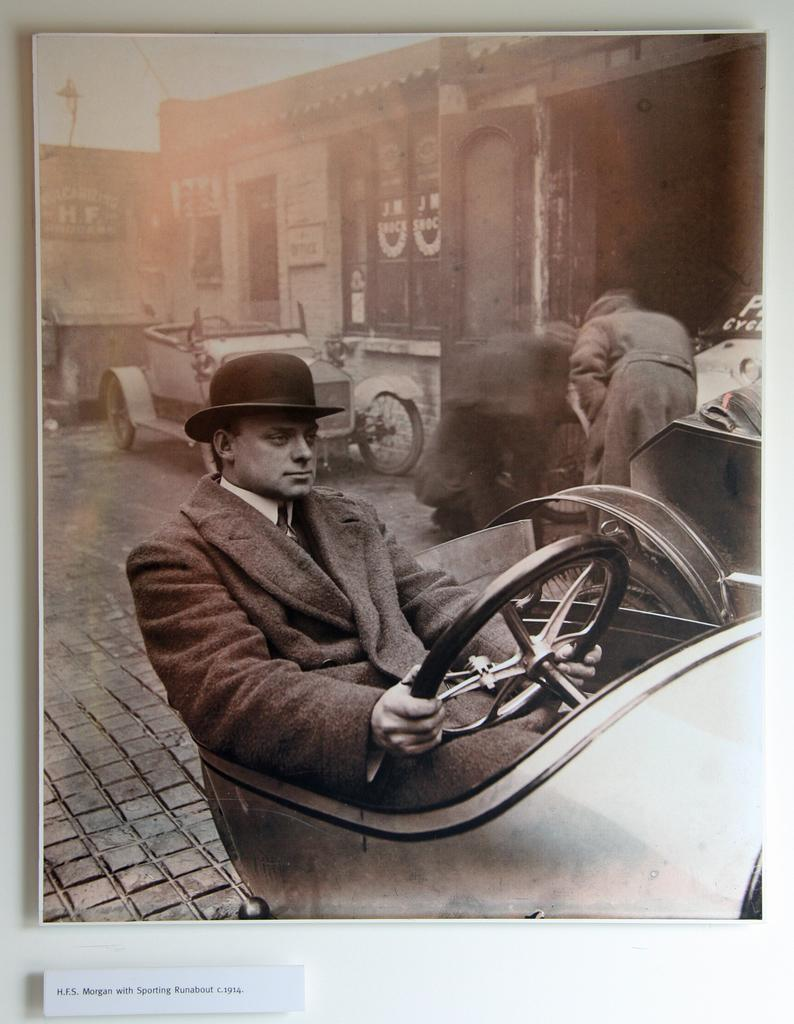What is the man in the image doing? The man is driving a vehicle in the image. Can you describe the man's attire? The man is wearing a cap. What can be seen in the background of the image? There is a house in the background of the image. Are there any other vehicles visible in the image? Yes, there is a vehicle in front of the house in the background. What type of food is being prepared in the vehicle? There is no food preparation visible in the image; the man is simply driving a vehicle. 